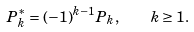Convert formula to latex. <formula><loc_0><loc_0><loc_500><loc_500>P _ { k } ^ { * } = ( - 1 ) ^ { k - 1 } P _ { k } , \quad k \geq 1 .</formula> 